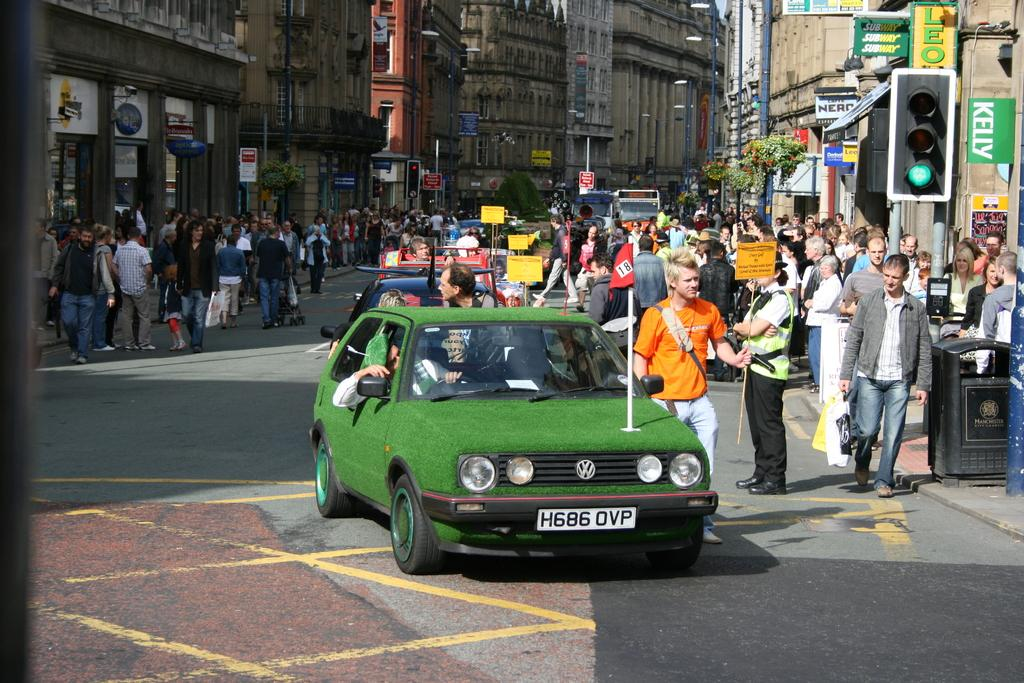<image>
Write a terse but informative summary of the picture. The green VW car has a red flag with the number 18 on it. 